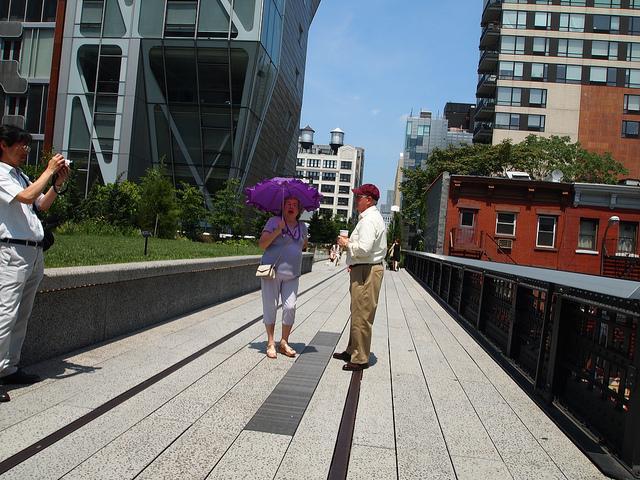The tanks seen in the background above the building once held what?
Indicate the correct choice and explain in the format: 'Answer: answer
Rationale: rationale.'
Options: Butane, oil, propane, water. Answer: water.
Rationale: The big tanks are water tanks. 